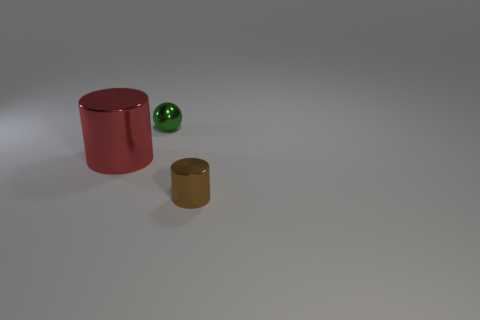What number of cubes are either tiny yellow metal things or large red things?
Your answer should be compact. 0. There is a tiny thing that is behind the cylinder that is on the right side of the red shiny cylinder; what is its color?
Your answer should be compact. Green. There is a brown object that is the same material as the green thing; what is its size?
Offer a terse response. Small. There is a cylinder on the left side of the object behind the red cylinder; are there any green shiny balls on the left side of it?
Offer a very short reply. No. How many green metal spheres have the same size as the green metal thing?
Your answer should be compact. 0. There is a shiny cylinder that is in front of the large metal cylinder; does it have the same size as the thing behind the big red cylinder?
Offer a terse response. Yes. What shape is the shiny thing that is both on the right side of the red thing and behind the brown cylinder?
Your answer should be compact. Sphere. Are any large cyan things visible?
Ensure brevity in your answer.  No. What is the color of the tiny shiny thing in front of the red metallic cylinder?
Provide a succinct answer. Brown. Is the size of the brown metal cylinder the same as the metal object that is behind the red cylinder?
Keep it short and to the point. Yes. 